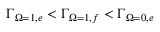<formula> <loc_0><loc_0><loc_500><loc_500>{ \Gamma } _ { { \Omega } = 1 , e } < { \Gamma } _ { { \Omega } = 1 , f } < { \Gamma } _ { { \Omega } = 0 , e }</formula> 